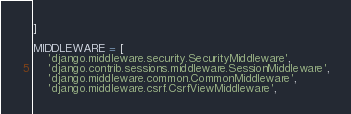<code> <loc_0><loc_0><loc_500><loc_500><_Python_>]

MIDDLEWARE = [
    'django.middleware.security.SecurityMiddleware',
    'django.contrib.sessions.middleware.SessionMiddleware',
    'django.middleware.common.CommonMiddleware',
    'django.middleware.csrf.CsrfViewMiddleware',</code> 